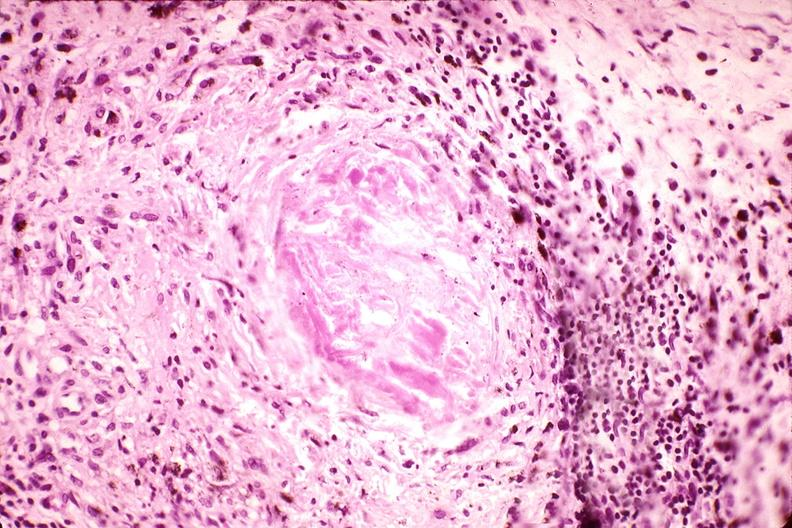does this image show synovium, pannus and fibrinoid necrosis, rheumatoid arthritis?
Answer the question using a single word or phrase. Yes 